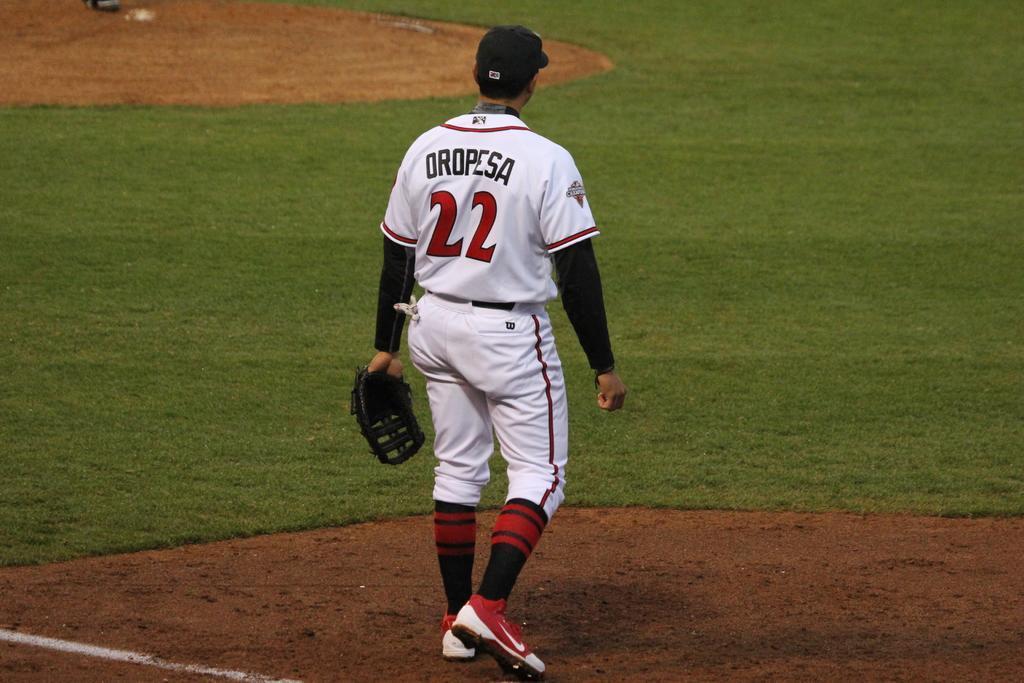<image>
Offer a succinct explanation of the picture presented. Oropesa is the name featured on the back of the jersey. 